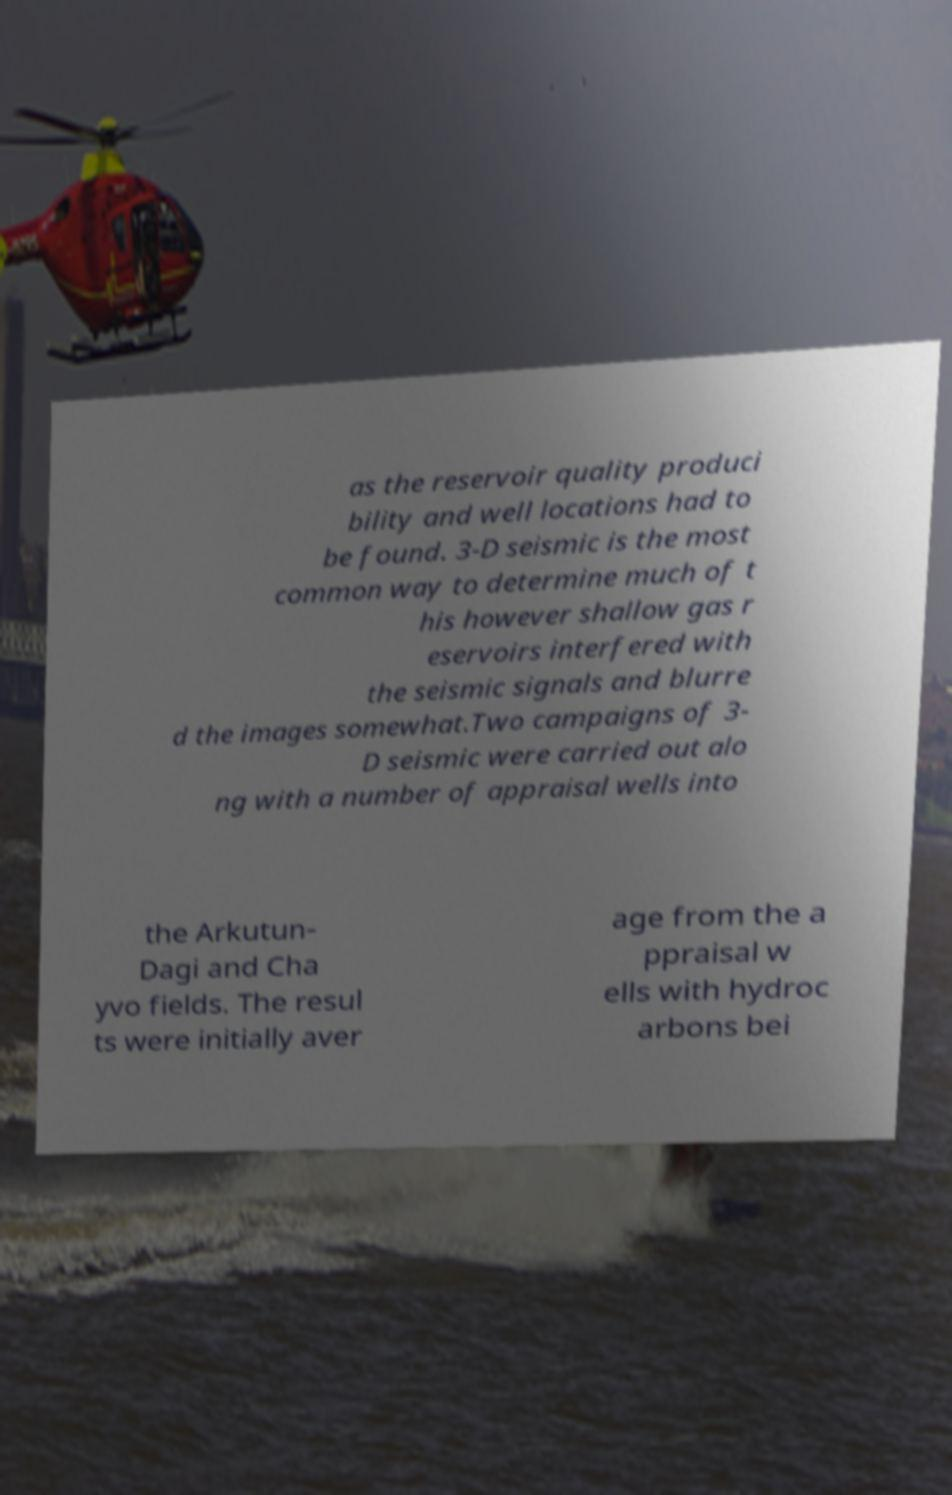Please identify and transcribe the text found in this image. as the reservoir quality produci bility and well locations had to be found. 3-D seismic is the most common way to determine much of t his however shallow gas r eservoirs interfered with the seismic signals and blurre d the images somewhat.Two campaigns of 3- D seismic were carried out alo ng with a number of appraisal wells into the Arkutun- Dagi and Cha yvo fields. The resul ts were initially aver age from the a ppraisal w ells with hydroc arbons bei 